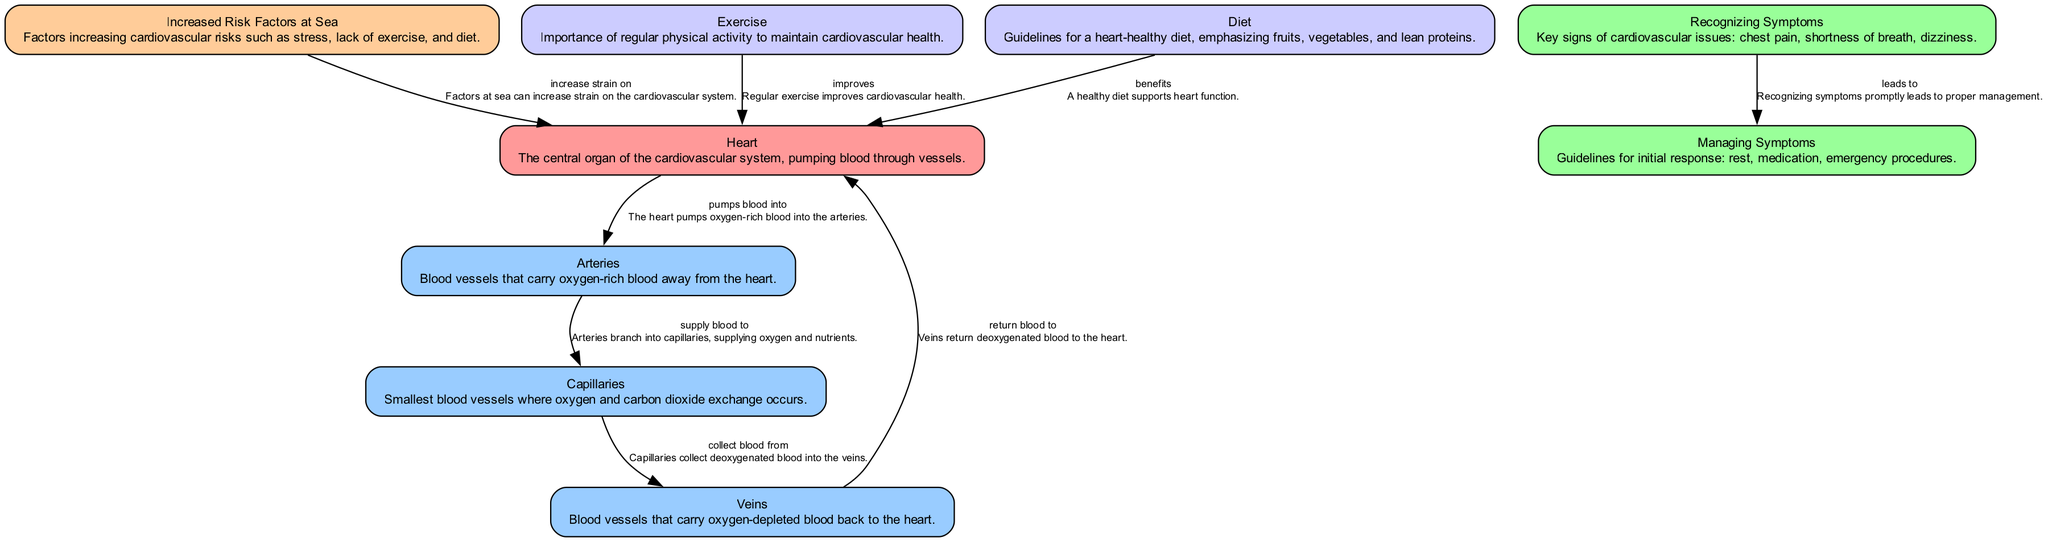What is the central organ of the cardiovascular system? The diagram identifies the "Heart" as the central organ of the cardiovascular system, responsible for pumping blood.
Answer: Heart How do arteries function in the cardiovascular system? The edges connected to "Arteries" show that they carry oxygen-rich blood away from the heart, indicating their role in blood circulation.
Answer: Supply blood to capillaries What do veins do in the cardiovascular system? The diagram shows that veins collect oxygen-depleted blood from capillaries and return it to the heart.
Answer: Return blood to heart How many nodes represent parts of the blood vessels in the diagram? The nodes representing blood vessels are "Arteries," "Veins," and "Capillaries," which totals to three nodes.
Answer: Three What increases strain on the heart according to the diagram? The edge connecting "Increased Risk Factors at Sea" to "Heart" indicates that these factors increase cardiovascular strain.
Answer: Increased Risk Factors at Sea What are key signs of cardiovascular issues? The "Recognizing Symptoms" node lists chest pain, shortness of breath, and dizziness as key signs of cardiovascular problems.
Answer: Chest pain, shortness of breath, dizziness How does regular exercise impact the heart? The diagram indicates that "Exercise" improves cardiovascular health and directly benefits the heart's function.
Answer: Improves cardiovascular health What leads to proper management of cardiovascular symptoms? The edge from "Recognizing Symptoms" to "Managing Symptoms" shows that acknowledging symptoms leads to appropriate management responses.
Answer: Recognizing symptoms What dietary habits benefit heart function? The "Diet" node explains that a heart-healthy diet emphasizing fruits, vegetables, and lean proteins benefits heart function.
Answer: A heart-healthy diet 